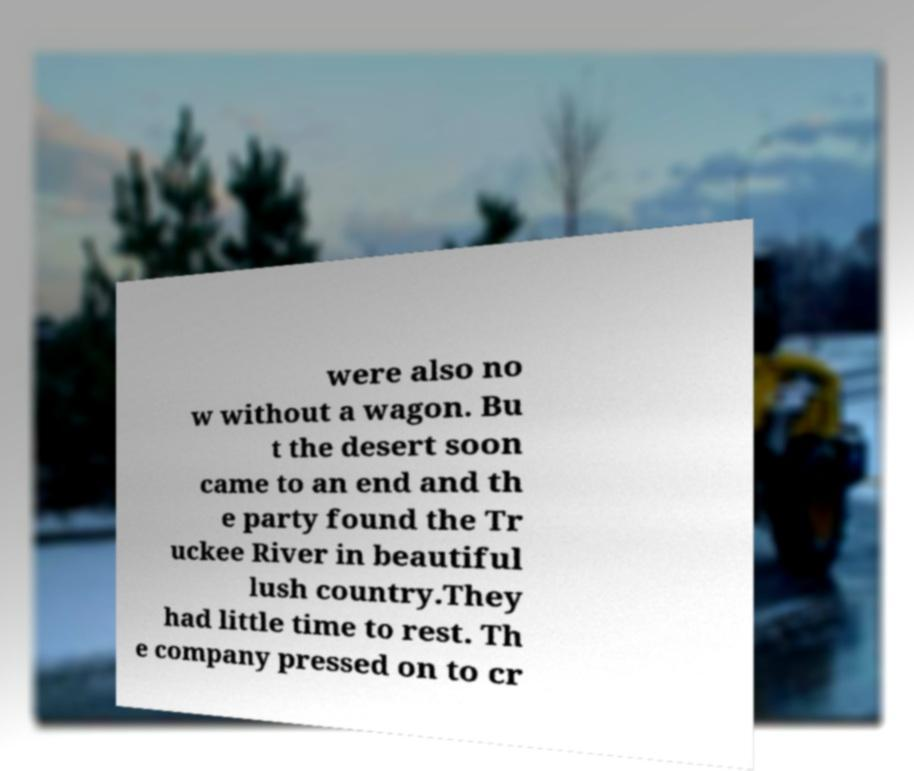For documentation purposes, I need the text within this image transcribed. Could you provide that? were also no w without a wagon. Bu t the desert soon came to an end and th e party found the Tr uckee River in beautiful lush country.They had little time to rest. Th e company pressed on to cr 